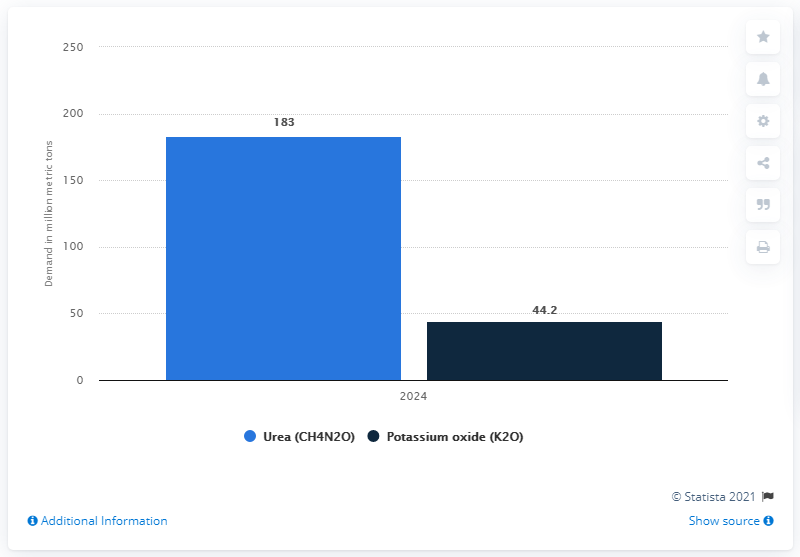Give some essential details in this illustration. The medium-term forecast for global fertilizer demand by nutrient for urea and potassium oxide predicts a demand of 227.2 units for each nutrient by 2024. It is forecasted that the global demand for fertilizer by nutrient will occur in 2024. The medium-term forecast for global fertilizer demand by nutrient for urea is expected to reach 183 million metric tons by 2024. 